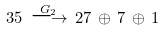Convert formula to latex. <formula><loc_0><loc_0><loc_500><loc_500>3 5 \, \stackrel { G _ { 2 } } { \longrightarrow } \, 2 7 \, \oplus \, 7 \, \oplus \, 1</formula> 